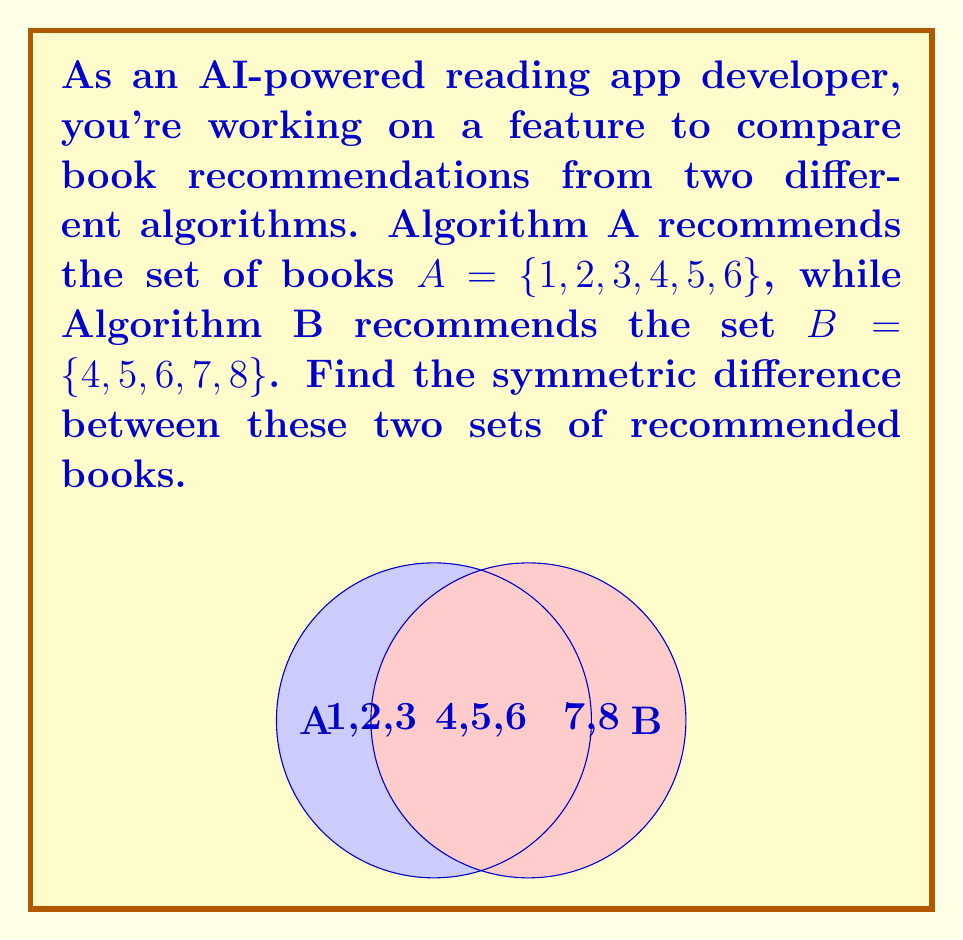Could you help me with this problem? To find the symmetric difference between two sets, we need to follow these steps:

1) Recall that the symmetric difference of sets A and B, denoted as $A \triangle B$, is defined as:

   $A \triangle B = (A \setminus B) \cup (B \setminus A)$

   This means we need to find elements that are in A but not in B, and elements that are in B but not in A, then unite these two results.

2) Let's find $A \setminus B$ first:
   $A \setminus B = \{1, 2, 3\}$

3) Now, let's find $B \setminus A$:
   $B \setminus A = \{7, 8\}$

4) The symmetric difference is the union of these two sets:
   $A \triangle B = \{1, 2, 3\} \cup \{7, 8\} = \{1, 2, 3, 7, 8\}$

5) We can verify this result by noting that these are indeed the elements that are in either A or B, but not in both.

This symmetric difference represents books that are recommended by only one of the algorithms, which could be useful for analyzing the differences in their recommendation patterns.
Answer: $\{1, 2, 3, 7, 8\}$ 